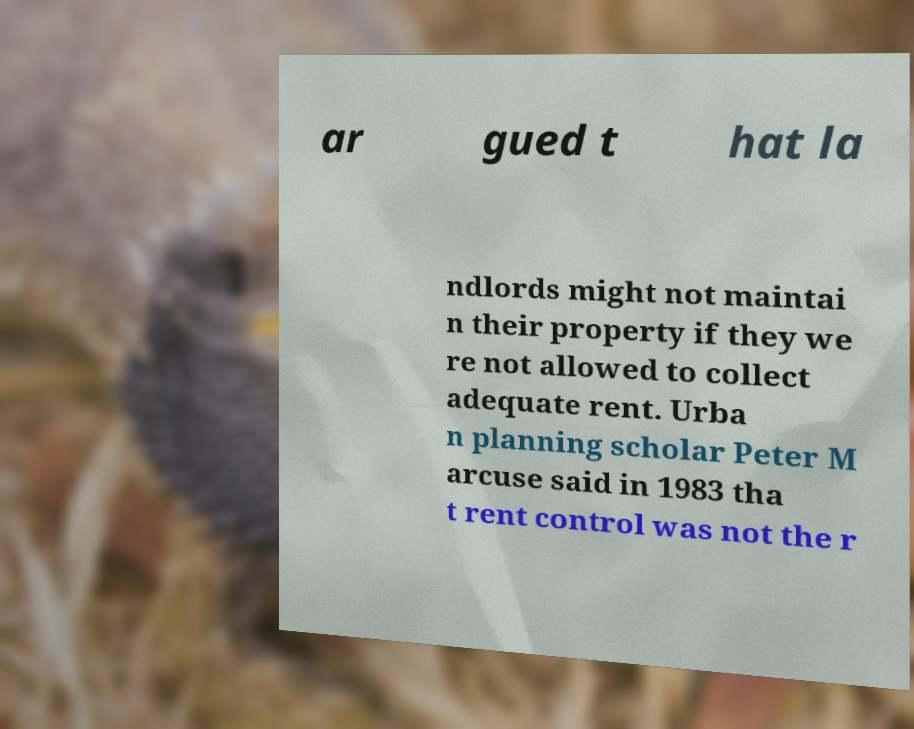Could you extract and type out the text from this image? ar gued t hat la ndlords might not maintai n their property if they we re not allowed to collect adequate rent. Urba n planning scholar Peter M arcuse said in 1983 tha t rent control was not the r 